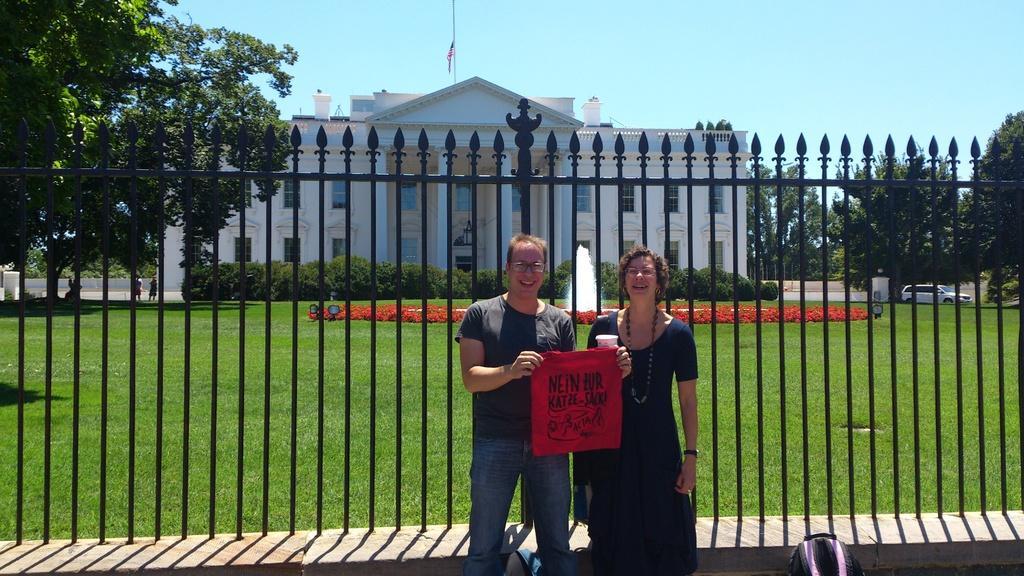In one or two sentences, can you explain what this image depicts? In the middle a man is standing, he wore a t-shirt, trouser. On the right side there is a woman she wore dress. Behind them it's an iron grill. At the backside of an image there is a house. 